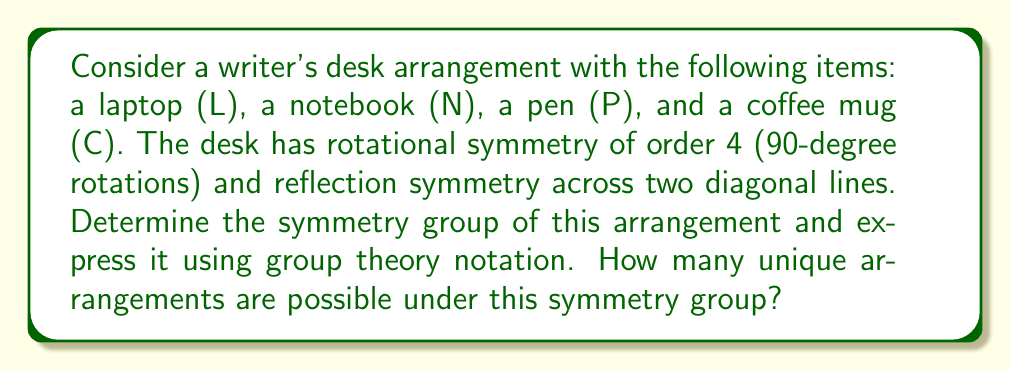Teach me how to tackle this problem. Let's approach this step-by-step:

1) First, we need to identify the symmetries of the desk arrangement:
   - Rotations: 0°, 90°, 180°, 270° (clockwise)
   - Reflections: across two diagonal lines

2) These symmetries form the Dihedral group of order 8, denoted as $D_4$ or $D_8$ (depending on notation).

3) The elements of $D_4$ can be represented as:
   $$D_4 = \{e, r, r^2, r^3, f, fr, fr^2, fr^3\}$$
   where $e$ is the identity, $r$ is a 90° rotation, and $f$ is a reflection.

4) To determine the number of unique arrangements, we need to use Burnside's lemma:

   $$|X/G| = \frac{1}{|G|} \sum_{g \in G} |X^g|$$

   where $|X/G|$ is the number of orbits (unique arrangements),
   $|G|$ is the order of the group,
   and $|X^g|$ is the number of elements fixed by each group element $g$.

5) Let's count the fixed points for each symmetry:
   - $e$: fixes all 4! = 24 arrangements
   - $r, r^2, r^3$: fix only the arrangement where all items are in different quadrants (1 each)
   - $f, fr, fr^2, fr^3$: fix 2 arrangements each (when items are symmetric across the reflection line)

6) Applying Burnside's lemma:

   $$|X/G| = \frac{1}{8}(24 + 1 + 1 + 1 + 2 + 2 + 2 + 2) = \frac{35}{8} = 4.375$$

7) Since the number of unique arrangements must be an integer, we round down to 4.
Answer: The symmetry group of the writer's desk arrangement is the Dihedral group $D_4$, and there are 4 unique arrangements possible under this symmetry group. 